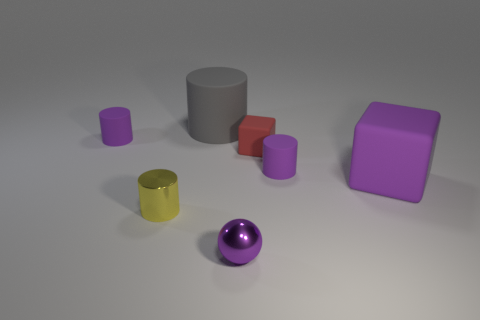There is a tiny cylinder that is on the left side of the gray matte cylinder and behind the large purple cube; what color is it?
Keep it short and to the point. Purple. What is the purple cylinder that is to the left of the large gray thing made of?
Keep it short and to the point. Rubber. Is there a tiny red object that has the same shape as the big purple matte object?
Provide a succinct answer. Yes. How many other things are there of the same shape as the large gray rubber thing?
Give a very brief answer. 3. Does the gray rubber thing have the same shape as the tiny purple matte object that is right of the big matte cylinder?
Your response must be concise. Yes. Are there any other things that are made of the same material as the tiny ball?
Your answer should be very brief. Yes. There is a big purple thing that is the same shape as the tiny red rubber thing; what is it made of?
Keep it short and to the point. Rubber. How many large objects are either purple rubber things or red cubes?
Provide a succinct answer. 1. Is the number of small purple matte cylinders that are left of the gray cylinder less than the number of tiny things that are in front of the small yellow object?
Provide a short and direct response. No. How many things are either small rubber blocks or cyan rubber blocks?
Provide a succinct answer. 1. 